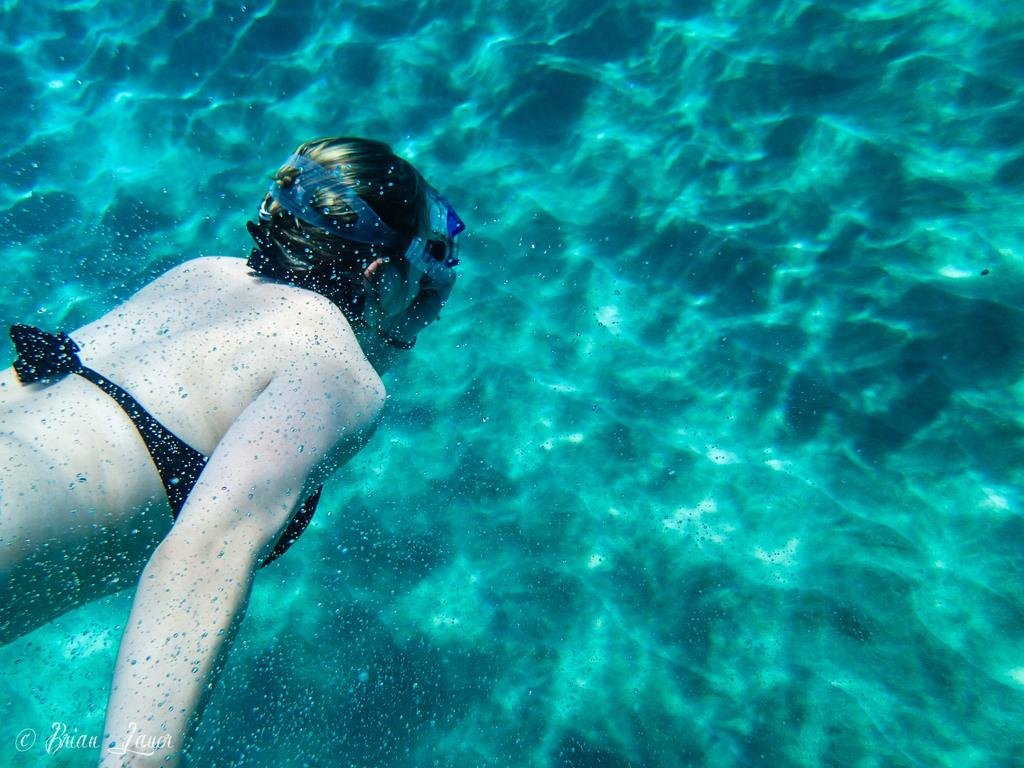Who is present in the image? There is a woman in the image. What is the woman doing in the image? The woman is swimming in the water. What is the woman wearing on her face while swimming? The woman is wearing a mask on her face. What type of gun is the woman holding while swimming in the image? There is no gun present in the image; the woman is wearing a mask on her face while swimming. 